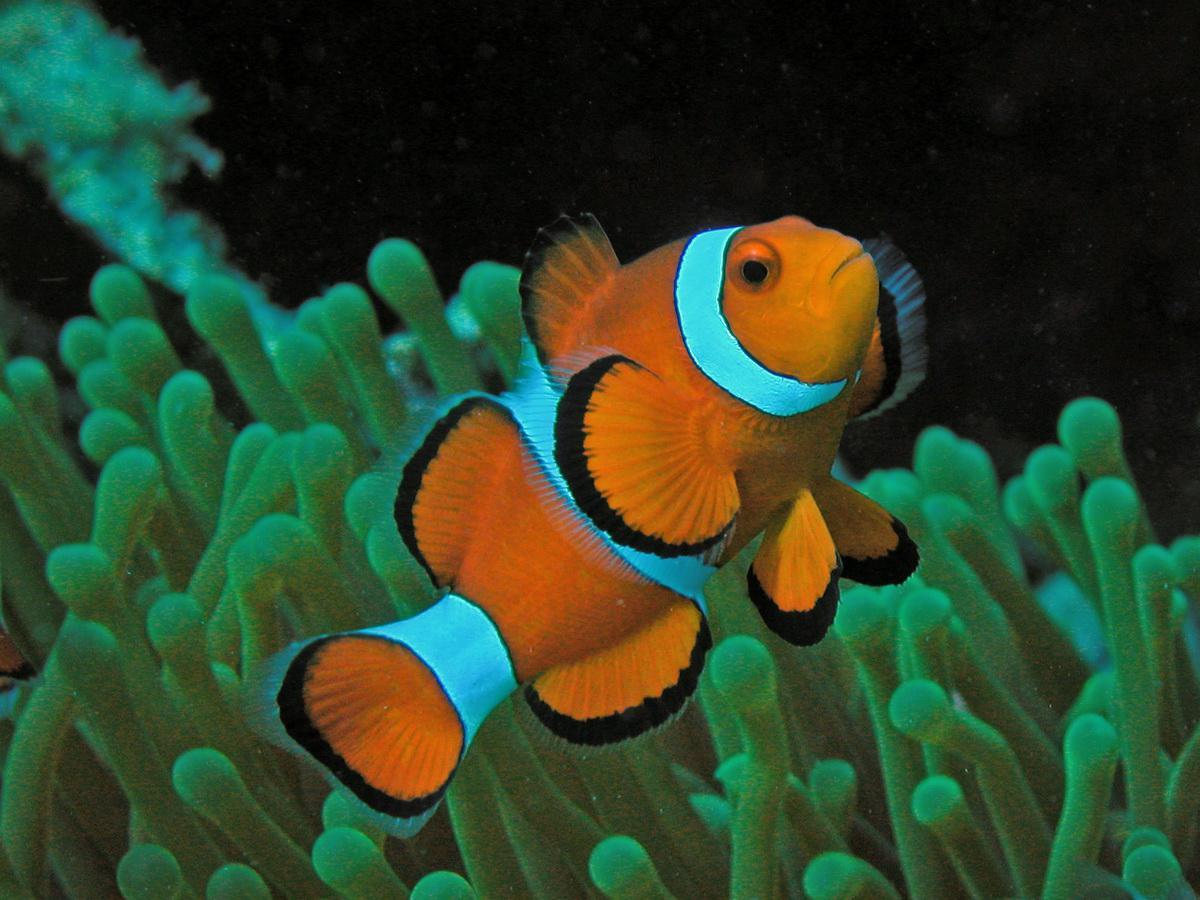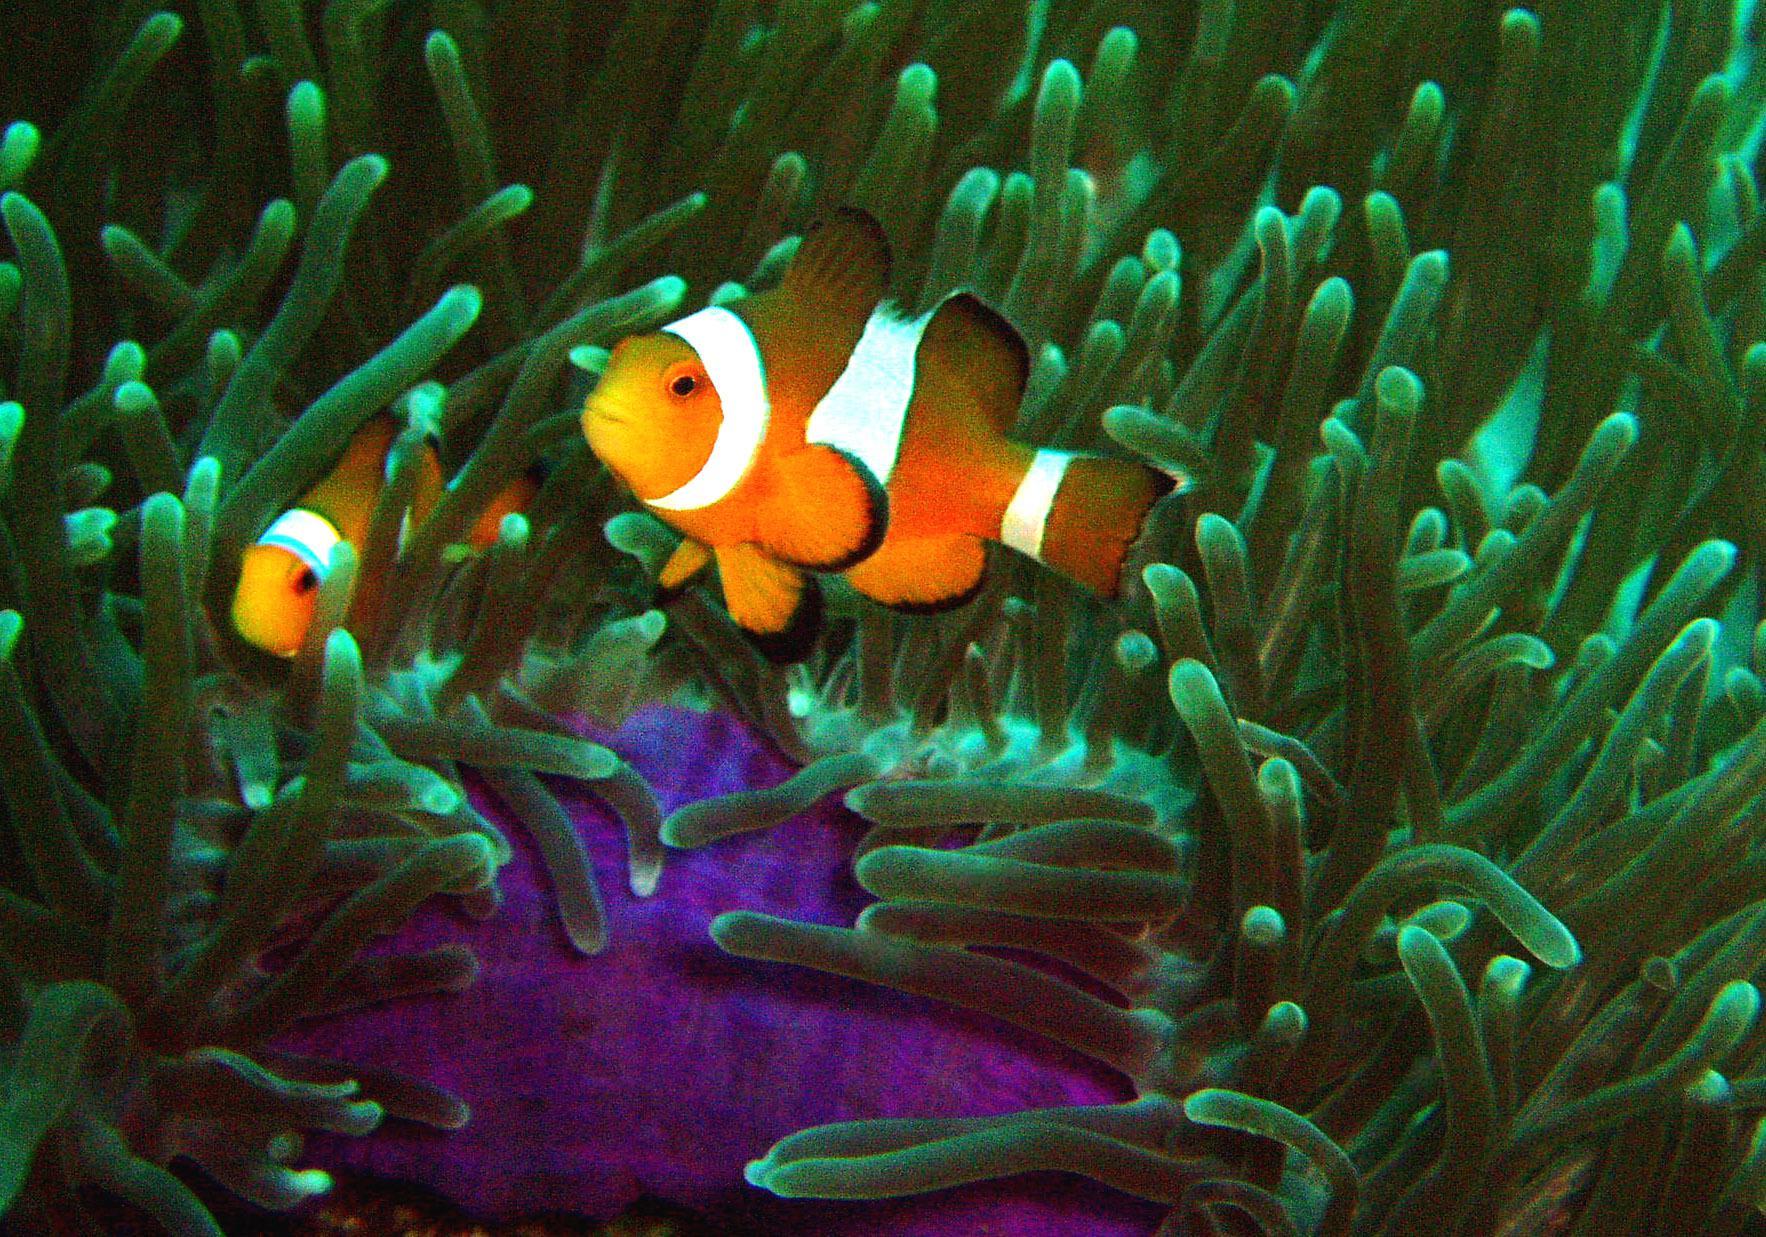The first image is the image on the left, the second image is the image on the right. Considering the images on both sides, is "A total of two clown fish are shown, facing opposite directions." valid? Answer yes or no. No. 